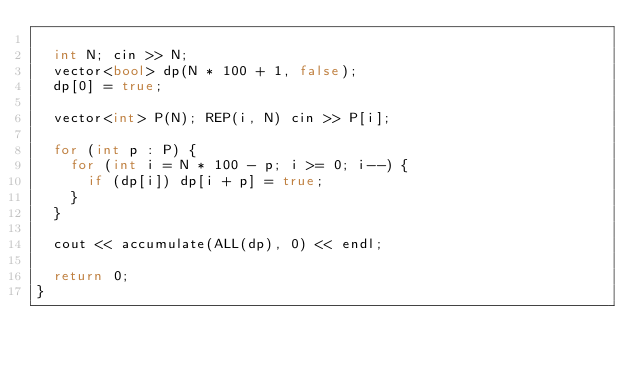<code> <loc_0><loc_0><loc_500><loc_500><_C++_>
  int N; cin >> N;
  vector<bool> dp(N * 100 + 1, false);
  dp[0] = true;

  vector<int> P(N); REP(i, N) cin >> P[i];

  for (int p : P) {
    for (int i = N * 100 - p; i >= 0; i--) {
      if (dp[i]) dp[i + p] = true;
    }
  }

  cout << accumulate(ALL(dp), 0) << endl;

  return 0;
}
</code> 